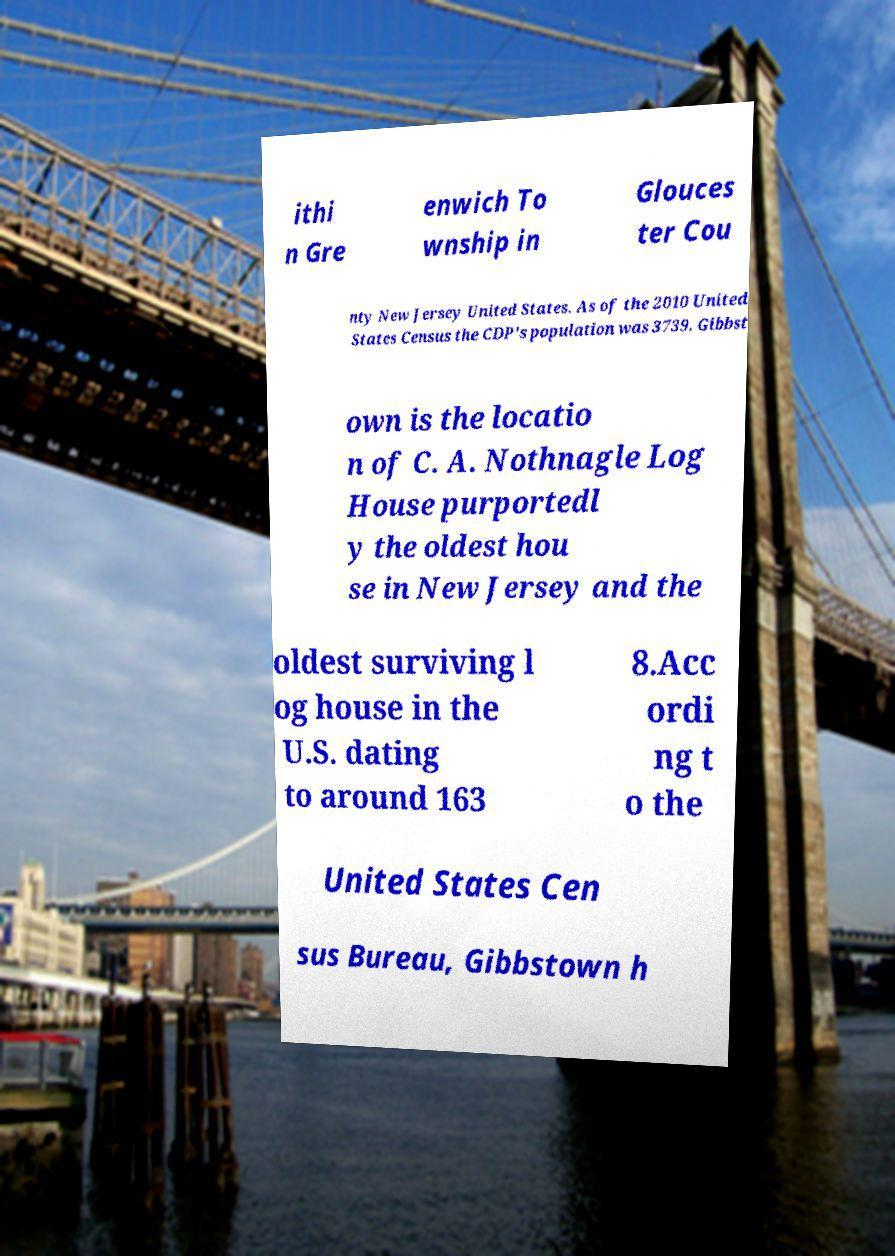Can you accurately transcribe the text from the provided image for me? ithi n Gre enwich To wnship in Glouces ter Cou nty New Jersey United States. As of the 2010 United States Census the CDP's population was 3739. Gibbst own is the locatio n of C. A. Nothnagle Log House purportedl y the oldest hou se in New Jersey and the oldest surviving l og house in the U.S. dating to around 163 8.Acc ordi ng t o the United States Cen sus Bureau, Gibbstown h 